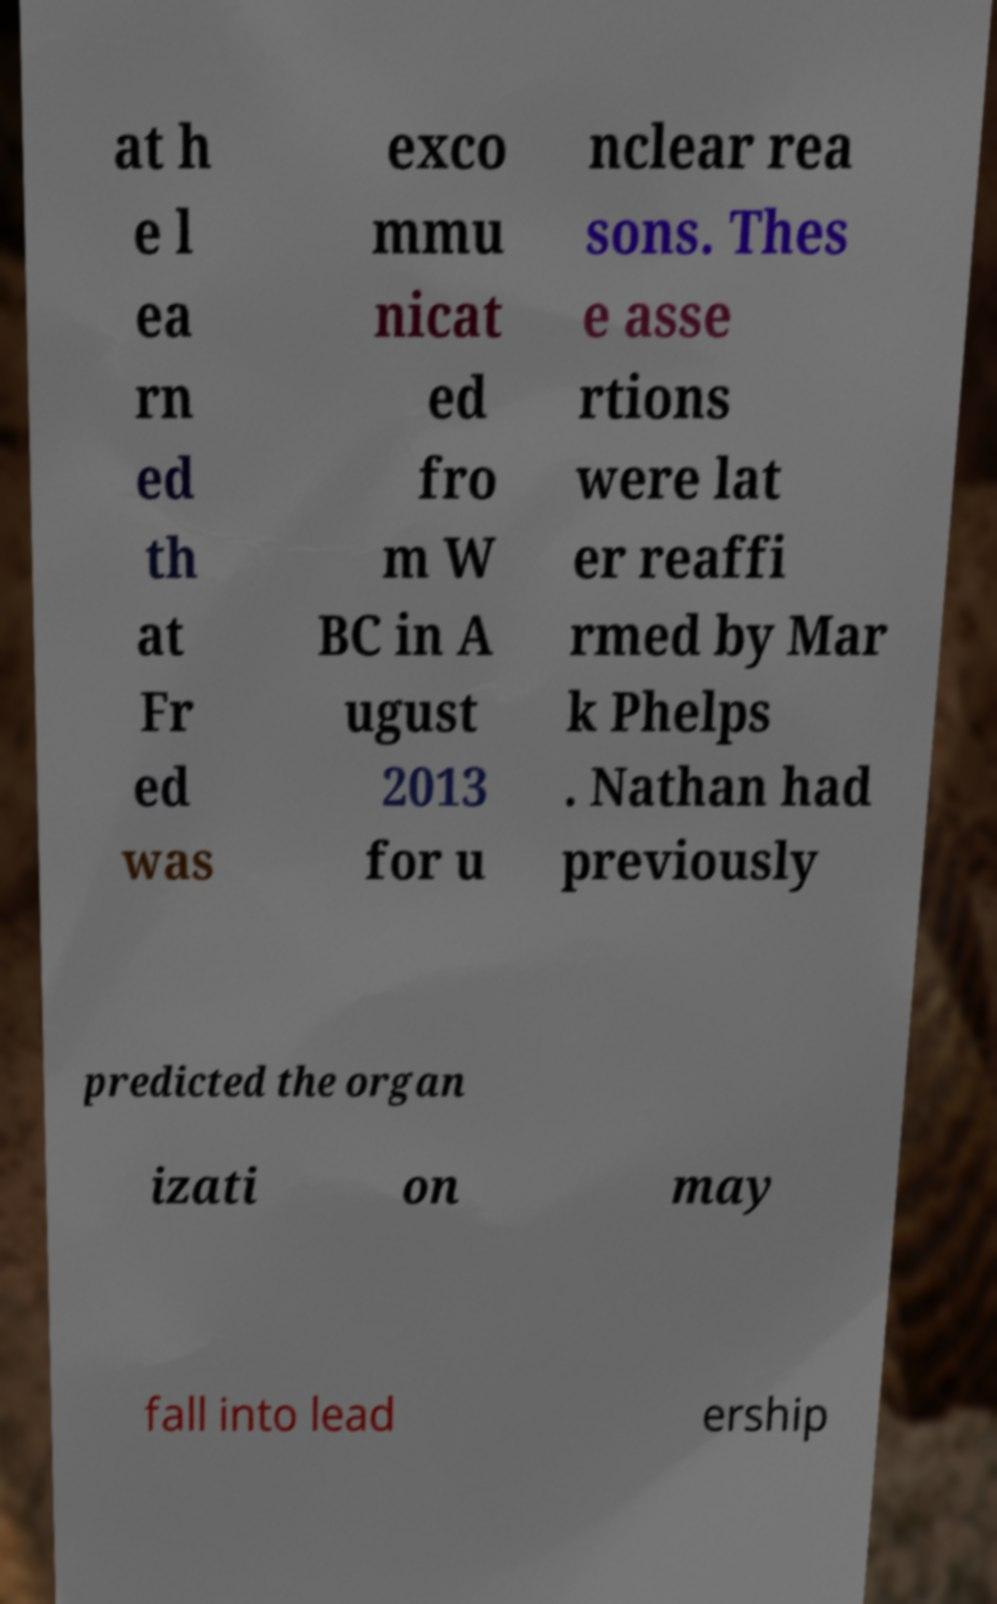Could you extract and type out the text from this image? at h e l ea rn ed th at Fr ed was exco mmu nicat ed fro m W BC in A ugust 2013 for u nclear rea sons. Thes e asse rtions were lat er reaffi rmed by Mar k Phelps . Nathan had previously predicted the organ izati on may fall into lead ership 